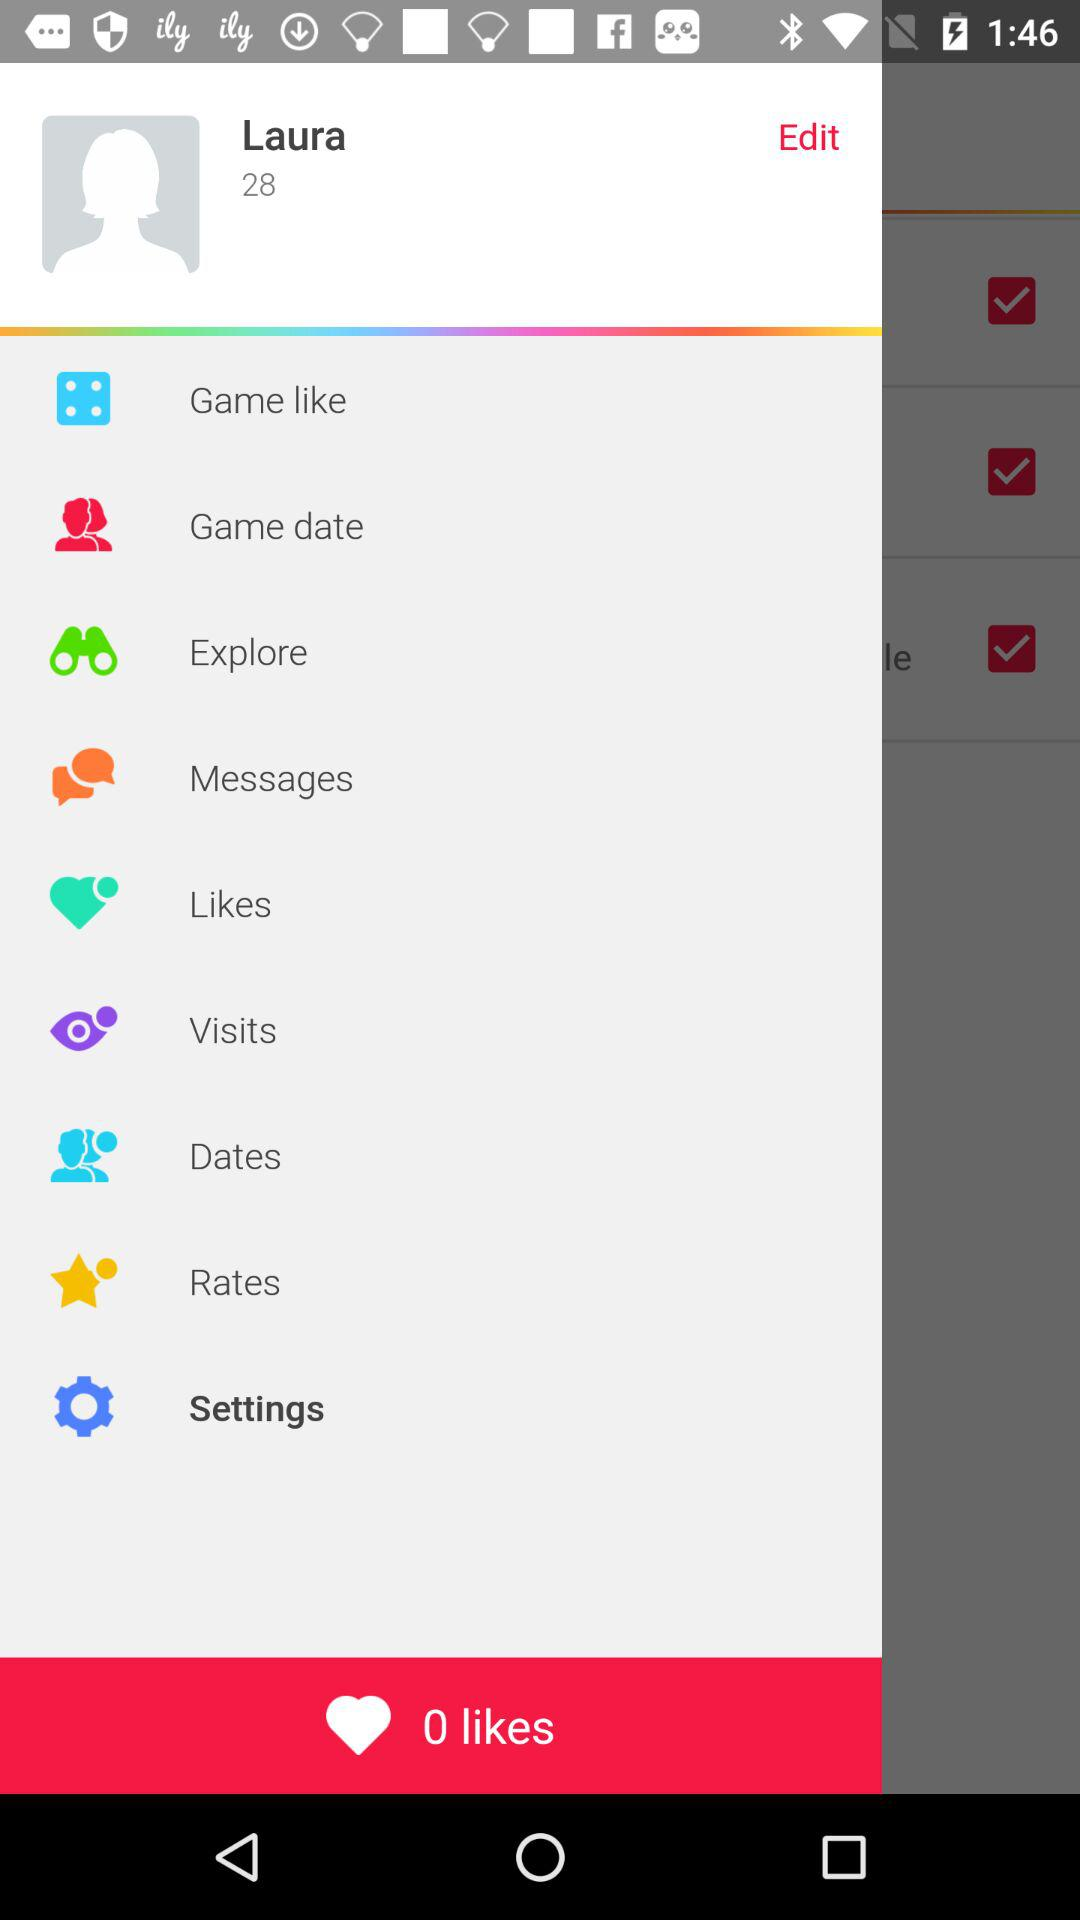What is the age of Laura? The age is 28 years. 